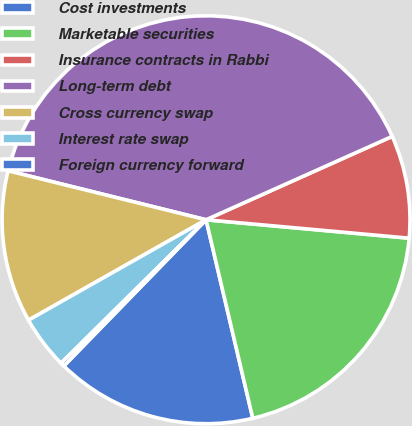Convert chart to OTSL. <chart><loc_0><loc_0><loc_500><loc_500><pie_chart><fcel>Cost investments<fcel>Marketable securities<fcel>Insurance contracts in Rabbi<fcel>Long-term debt<fcel>Cross currency swap<fcel>Interest rate swap<fcel>Foreign currency forward<nl><fcel>15.96%<fcel>19.88%<fcel>8.14%<fcel>39.44%<fcel>12.05%<fcel>4.22%<fcel>0.31%<nl></chart> 